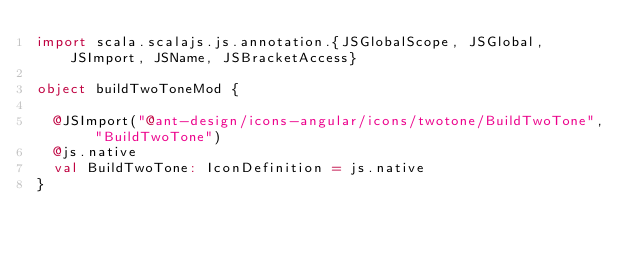Convert code to text. <code><loc_0><loc_0><loc_500><loc_500><_Scala_>import scala.scalajs.js.annotation.{JSGlobalScope, JSGlobal, JSImport, JSName, JSBracketAccess}

object buildTwoToneMod {
  
  @JSImport("@ant-design/icons-angular/icons/twotone/BuildTwoTone", "BuildTwoTone")
  @js.native
  val BuildTwoTone: IconDefinition = js.native
}
</code> 